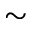<formula> <loc_0><loc_0><loc_500><loc_500>\sim</formula> 